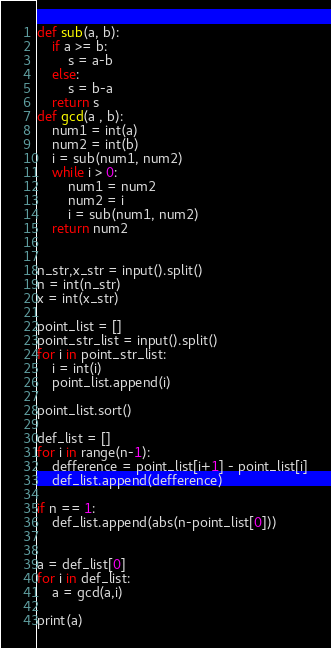Convert code to text. <code><loc_0><loc_0><loc_500><loc_500><_Python_>def sub(a, b):
    if a >= b:
        s = a-b
    else:
        s = b-a
    return s
def gcd(a , b):
    num1 = int(a)
    num2 = int(b)
    i = sub(num1, num2)
    while i > 0:
        num1 = num2
        num2 = i
        i = sub(num1, num2)
    return num2


n_str,x_str = input().split()
n = int(n_str)
x = int(x_str)

point_list = []
point_str_list = input().split()
for i in point_str_list:
    i = int(i)
    point_list.append(i)

point_list.sort()

def_list = []
for i in range(n-1):
    defference = point_list[i+1] - point_list[i]
    def_list.append(defference)

if n == 1:
    def_list.append(abs(n-point_list[0]))


a = def_list[0]
for i in def_list:
    a = gcd(a,i)

print(a)
</code> 